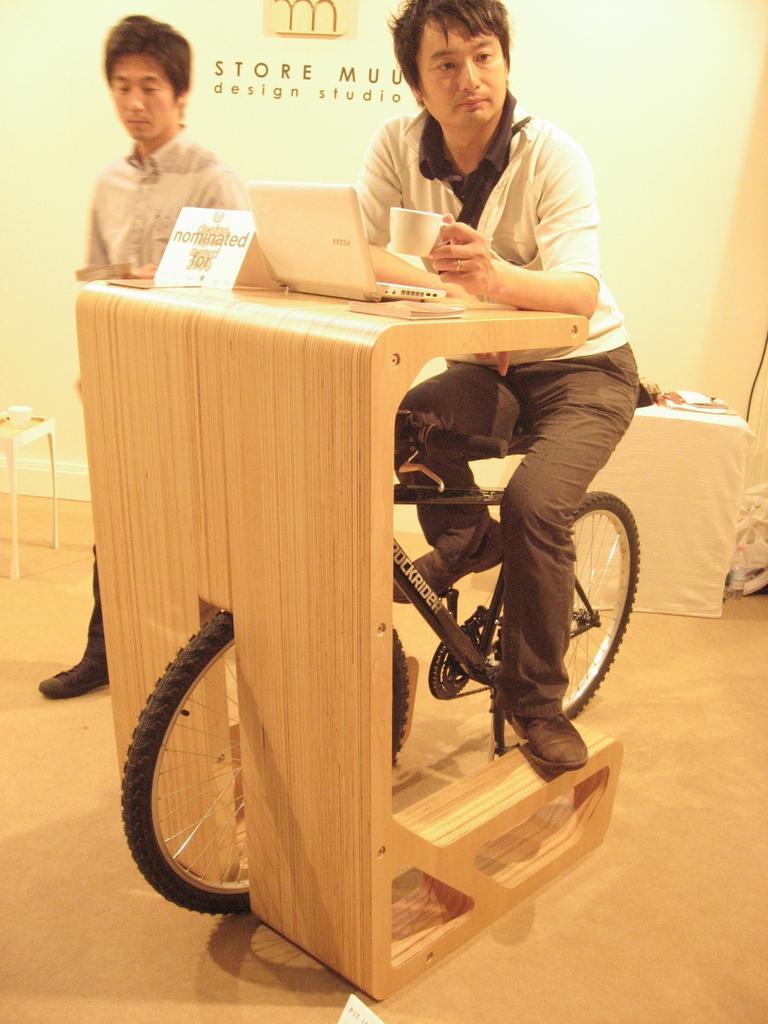Could you give a brief overview of what you see in this image? In this image these are the two persons visible ,one person standing on the left side of the image and another person sit on the cycle and it is kept on the wooden table. on the table there is a laptop. 